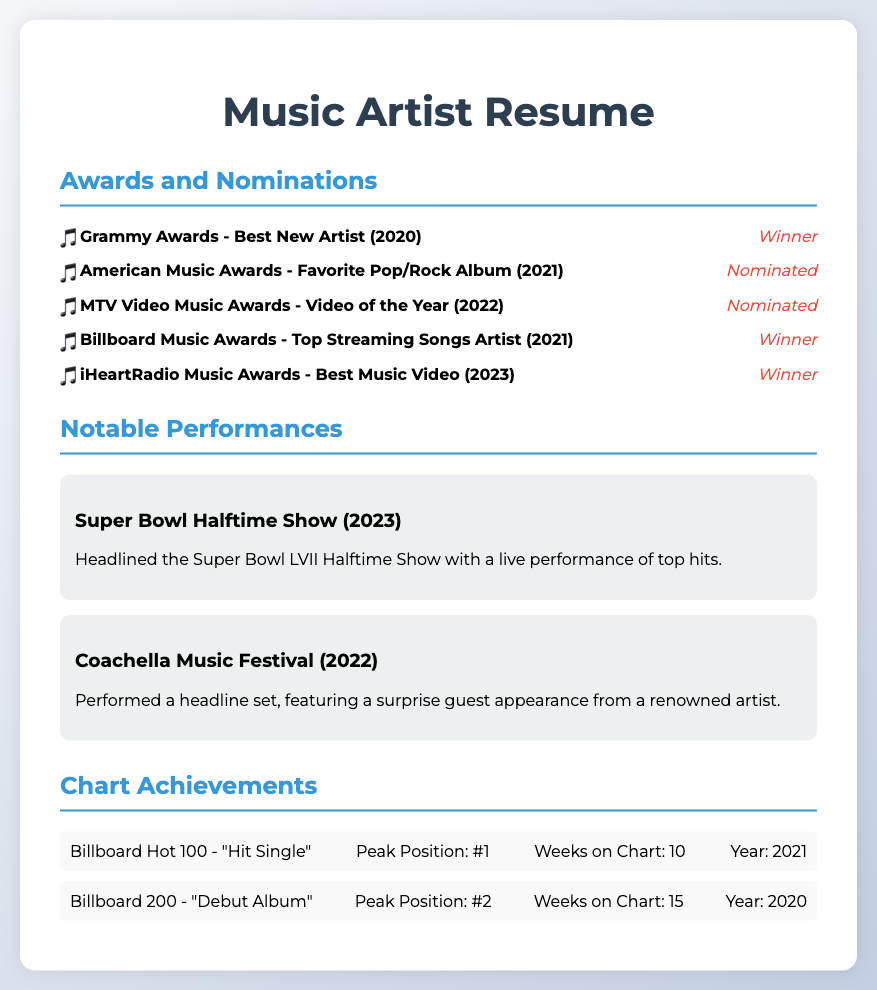What award did the artist win in 2020? The artist won the Grammy Awards for Best New Artist in 2020.
Answer: Best New Artist How many nominations did the artist receive in 2021? The artist received one nomination for the American Music Awards - Favorite Pop/Rock Album in 2021.
Answer: 1 What was the result of the MTV Video Music Awards nomination in 2022? The artist was nominated for Video of the Year at the MTV Video Music Awards in 2022.
Answer: Nominated Which award did the artist win in 2023? The artist won the iHeartRadio Music Awards for Best Music Video in 2023.
Answer: Best Music Video What is the peak position of the artist's "Hit Single" on the Billboard Hot 100? The peak position of the "Hit Single" on the Billboard Hot 100 was #1.
Answer: #1 What notable event did the artist headline in 2023? The artist headlined the Super Bowl LVII Halftime Show in 2023.
Answer: Super Bowl LVII Halftime Show Which award category was the artist nominated for in 2021? The artist was nominated for Favorite Pop/Rock Album at the American Music Awards in 2021.
Answer: Favorite Pop/Rock Album How long did the "Hit Single" stay on the Billboard Hot 100 chart? The "Hit Single" stayed on the Billboard Hot 100 chart for 10 weeks.
Answer: 10 weeks What was the result of the artist at the Billboard Music Awards in 2021? The artist won the Billboard Music Award for Top Streaming Songs Artist in 2021.
Answer: Winner 